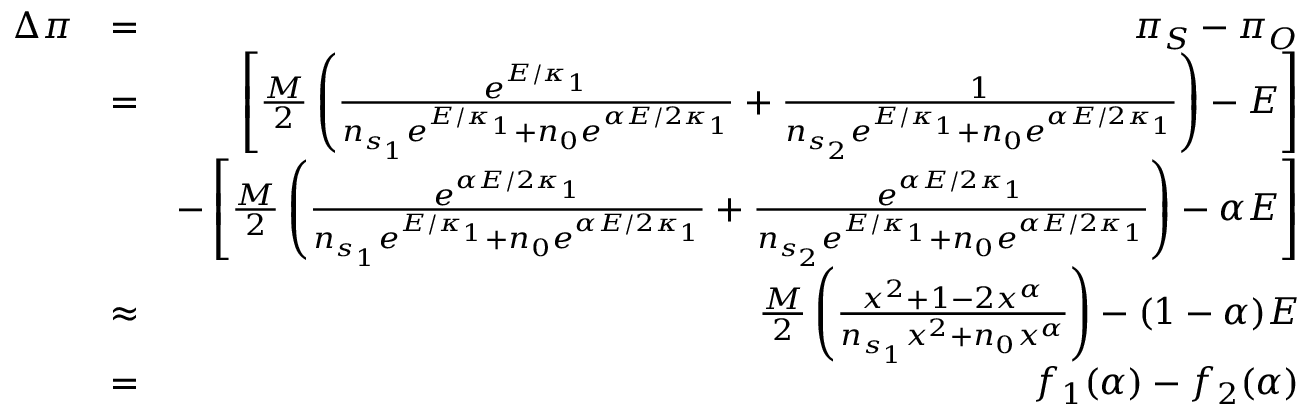<formula> <loc_0><loc_0><loc_500><loc_500>\begin{array} { r l r } { \Delta \pi } & { = } & { \pi _ { S } - \pi _ { O } } \\ & { = } & { \left [ \frac { M } { 2 } \left ( \frac { e ^ { E / \kappa _ { 1 } } } { n _ { s _ { 1 } } e ^ { E / \kappa _ { 1 } } + n _ { 0 } e ^ { \alpha E / 2 \kappa _ { 1 } } } + \frac { 1 } { n _ { s _ { 2 } } e ^ { E / \kappa _ { 1 } } + n _ { 0 } e ^ { \alpha E / 2 \kappa _ { 1 } } } \right ) - E \right ] } \\ & { - \left [ \frac { M } { 2 } \left ( \frac { e ^ { \alpha E / 2 \kappa _ { 1 } } } { n _ { s _ { 1 } } e ^ { E / \kappa _ { 1 } } + n _ { 0 } e ^ { \alpha E / 2 \kappa _ { 1 } } } + \frac { e ^ { \alpha E / 2 \kappa _ { 1 } } } { n _ { s _ { 2 } } e ^ { E / \kappa _ { 1 } } + n _ { 0 } e ^ { \alpha E / 2 \kappa _ { 1 } } } \right ) - \alpha E \right ] } \\ & { \approx } & { \frac { M } { 2 } \left ( \frac { x ^ { 2 } + 1 - 2 x ^ { \alpha } } { n _ { s _ { 1 } } x ^ { 2 } + n _ { 0 } x ^ { \alpha } } \right ) - ( 1 - \alpha ) E } \\ & { = } & { f _ { 1 } ( \alpha ) - f _ { 2 } ( \alpha ) } \end{array}</formula> 